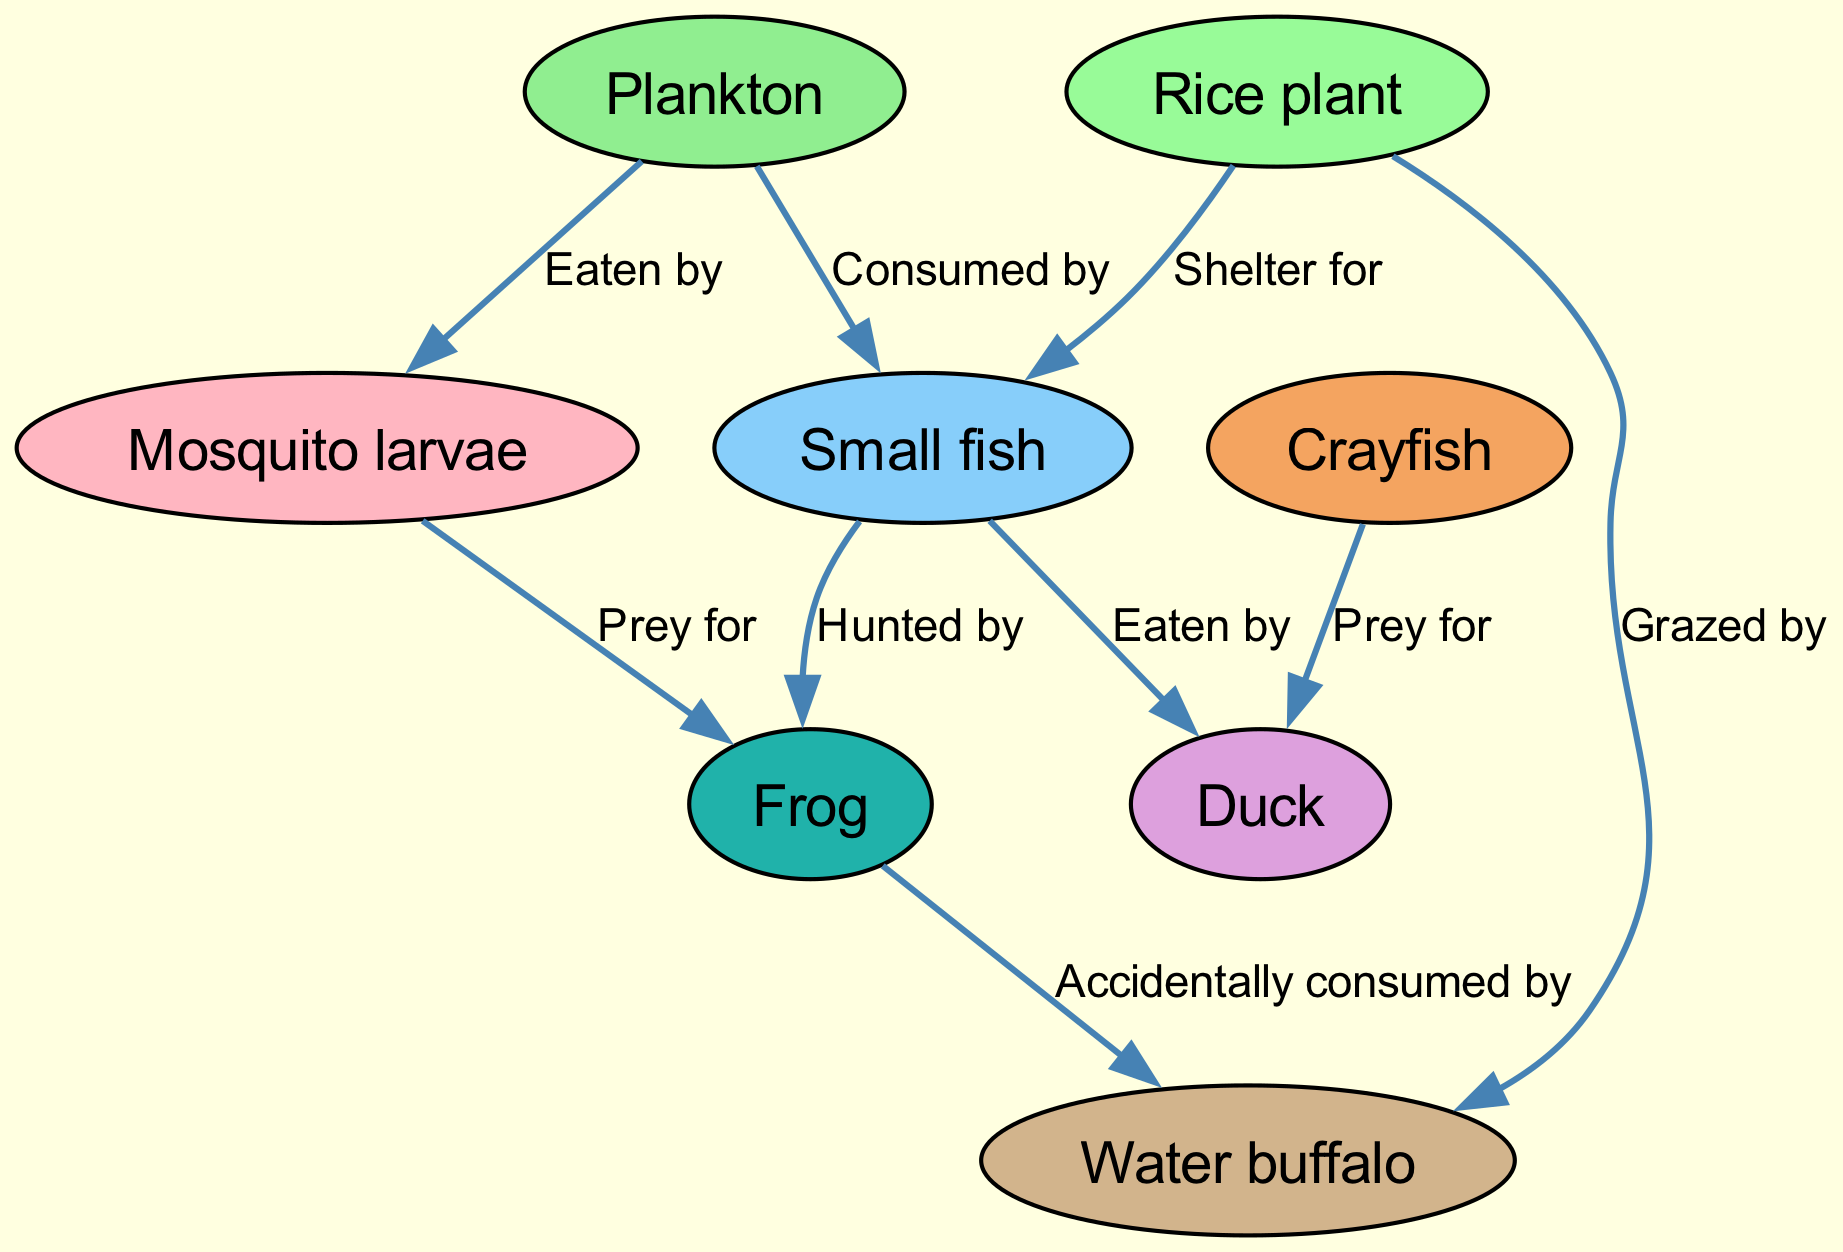What is the top node in the food chain? The top node in this food chain diagram is the Water buffalo, which is positioned at the end of the flow of energy. It does not have any predators shown in the diagram, indicating that it occupies a higher trophic level.
Answer: Water buffalo How many nodes are there in total? The total number of nodes is counted by listing each unique entity in the diagram representation. There are eight nodes: Plankton, Mosquito larvae, Small fish, Rice plant, Frog, Crayfish, Duck, and Water buffalo.
Answer: 8 Which organism is directly eaten by the Duck? To find the organism directly eaten by the Duck, we follow the outgoing edge from the Duck node; there are two incoming edges to it. One is from Small fish and the other from Crayfish, indicating both are its prey.
Answer: Small fish, Crayfish How many edges are there in the diagram? The edges in the diagram are counted by enumerating each connection between the nodes, which represents the flow of energy through predation and grazing. There are nine edges connecting the nodes.
Answer: 9 Who is at the bottom of the food chain? The bottom of the food chain typically consists of producers or primary consumers. In this case, the Plankton, as the primary producers, occupy the lowest level in the diagram without any organisms that consume them.
Answer: Plankton What relationship exists between the Rice plant and the Water buffalo? The relationship is defined by the edge that connects these two nodes. The Rice plant is grazed by the Water buffalo, indicating that the Water buffalo consumes the Rice plant as a food source.
Answer: Grazed by Which organism can accidentally consume the Frog? To determine which organism can accidentally consume the Frog, I look for any connections leading from the Frog to other nodes. The diagram shows an edge leading to the Water buffalo, indicating that this larger animal could accidentally consume the Frog while grazing.
Answer: Water buffalo Which two organisms share a prey relationship? A prey relationship can be identified by looking for edges that point from one organism to another. In this diagram, both the Mosquito larvae and the Small fish are prey for the Frog, indicating that both are hunted by the same predator.
Answer: Mosquito larvae, Small fish 